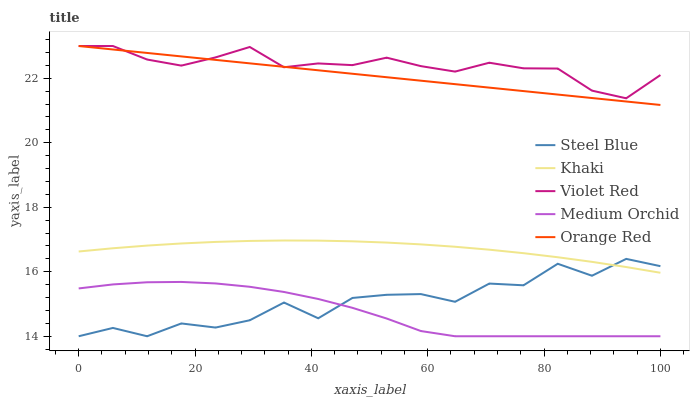Does Medium Orchid have the minimum area under the curve?
Answer yes or no. Yes. Does Violet Red have the maximum area under the curve?
Answer yes or no. Yes. Does Khaki have the minimum area under the curve?
Answer yes or no. No. Does Khaki have the maximum area under the curve?
Answer yes or no. No. Is Orange Red the smoothest?
Answer yes or no. Yes. Is Steel Blue the roughest?
Answer yes or no. Yes. Is Khaki the smoothest?
Answer yes or no. No. Is Khaki the roughest?
Answer yes or no. No. Does Khaki have the lowest value?
Answer yes or no. No. Does Orange Red have the highest value?
Answer yes or no. Yes. Does Khaki have the highest value?
Answer yes or no. No. Is Steel Blue less than Violet Red?
Answer yes or no. Yes. Is Orange Red greater than Steel Blue?
Answer yes or no. Yes. Does Violet Red intersect Orange Red?
Answer yes or no. Yes. Is Violet Red less than Orange Red?
Answer yes or no. No. Is Violet Red greater than Orange Red?
Answer yes or no. No. Does Steel Blue intersect Violet Red?
Answer yes or no. No. 